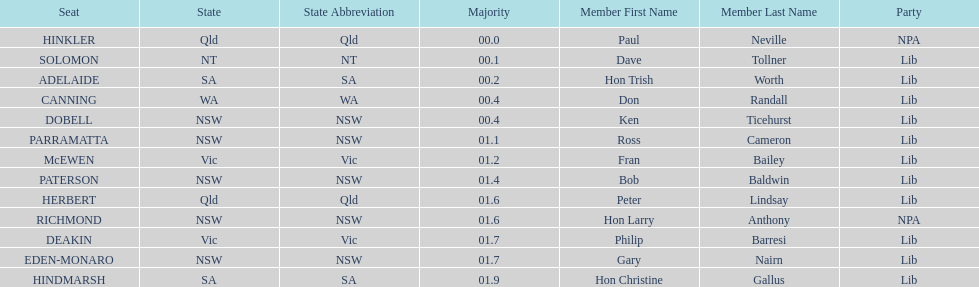Would you be able to parse every entry in this table? {'header': ['Seat', 'State', 'State Abbreviation', 'Majority', 'Member First Name', 'Member Last Name', 'Party'], 'rows': [['HINKLER', 'Qld', 'Qld', '00.0', 'Paul', 'Neville', 'NPA'], ['SOLOMON', 'NT', 'NT', '00.1', 'Dave', 'Tollner', 'Lib'], ['ADELAIDE', 'SA', 'SA', '00.2', 'Hon Trish', 'Worth', 'Lib'], ['CANNING', 'WA', 'WA', '00.4', 'Don', 'Randall', 'Lib'], ['DOBELL', 'NSW', 'NSW', '00.4', 'Ken', 'Ticehurst', 'Lib'], ['PARRAMATTA', 'NSW', 'NSW', '01.1', 'Ross', 'Cameron', 'Lib'], ['McEWEN', 'Vic', 'Vic', '01.2', 'Fran', 'Bailey', 'Lib'], ['PATERSON', 'NSW', 'NSW', '01.4', 'Bob', 'Baldwin', 'Lib'], ['HERBERT', 'Qld', 'Qld', '01.6', 'Peter', 'Lindsay', 'Lib'], ['RICHMOND', 'NSW', 'NSW', '01.6', 'Hon Larry', 'Anthony', 'NPA'], ['DEAKIN', 'Vic', 'Vic', '01.7', 'Philip', 'Barresi', 'Lib'], ['EDEN-MONARO', 'NSW', 'NSW', '01.7', 'Gary', 'Nairn', 'Lib'], ['HINDMARSH', 'SA', 'SA', '01.9', 'Hon Christine', 'Gallus', 'Lib']]} What party had the most seats? Lib. 